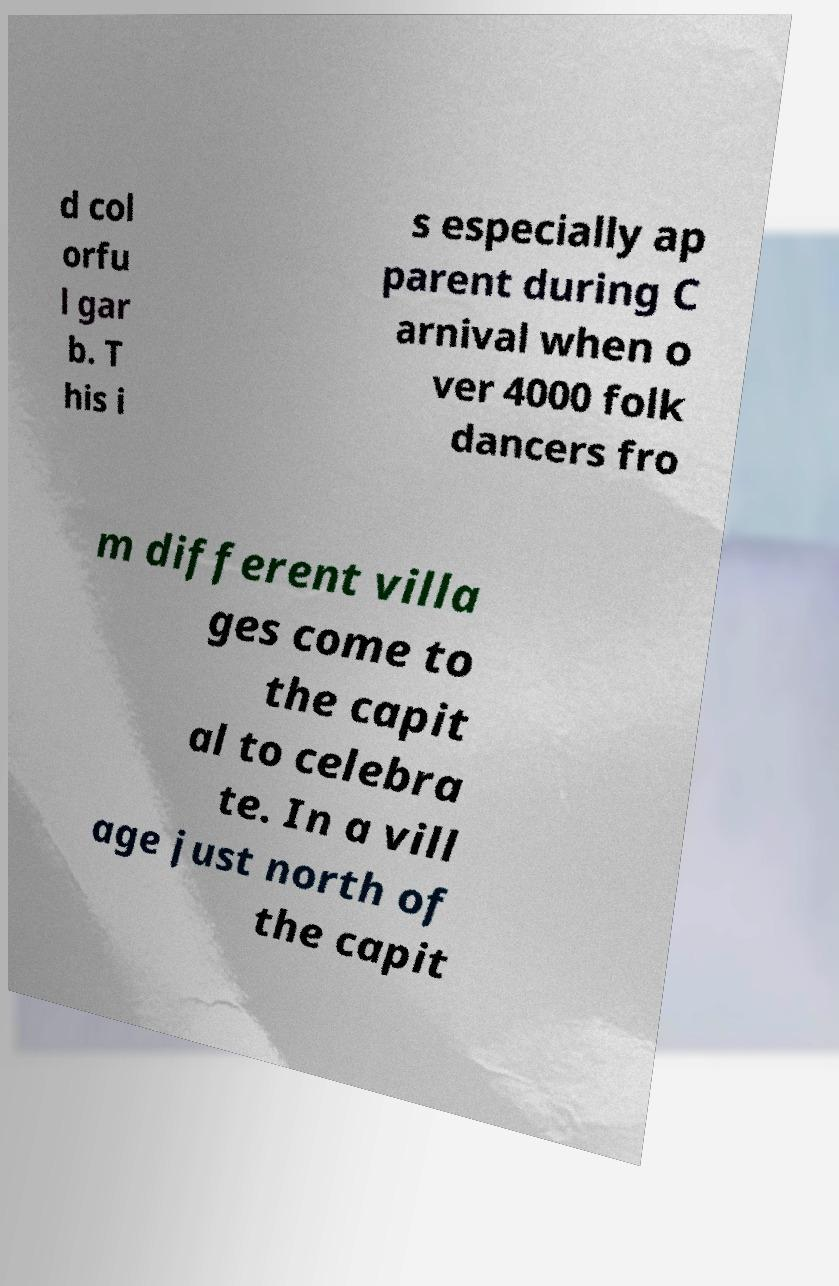Could you extract and type out the text from this image? d col orfu l gar b. T his i s especially ap parent during C arnival when o ver 4000 folk dancers fro m different villa ges come to the capit al to celebra te. In a vill age just north of the capit 